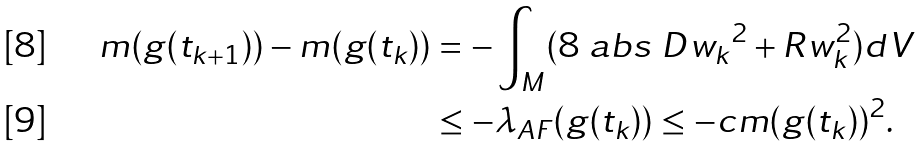<formula> <loc_0><loc_0><loc_500><loc_500>m ( g ( t _ { k + 1 } ) ) - m ( g ( t _ { k } ) ) & = - \int _ { M } ( 8 \ a b s { \ D w _ { k } } ^ { 2 } + R w _ { k } ^ { 2 } ) d V \\ & \leq - \lambda _ { A F } ( g ( t _ { k } ) ) \leq - c m ( g ( t _ { k } ) ) ^ { 2 } .</formula> 